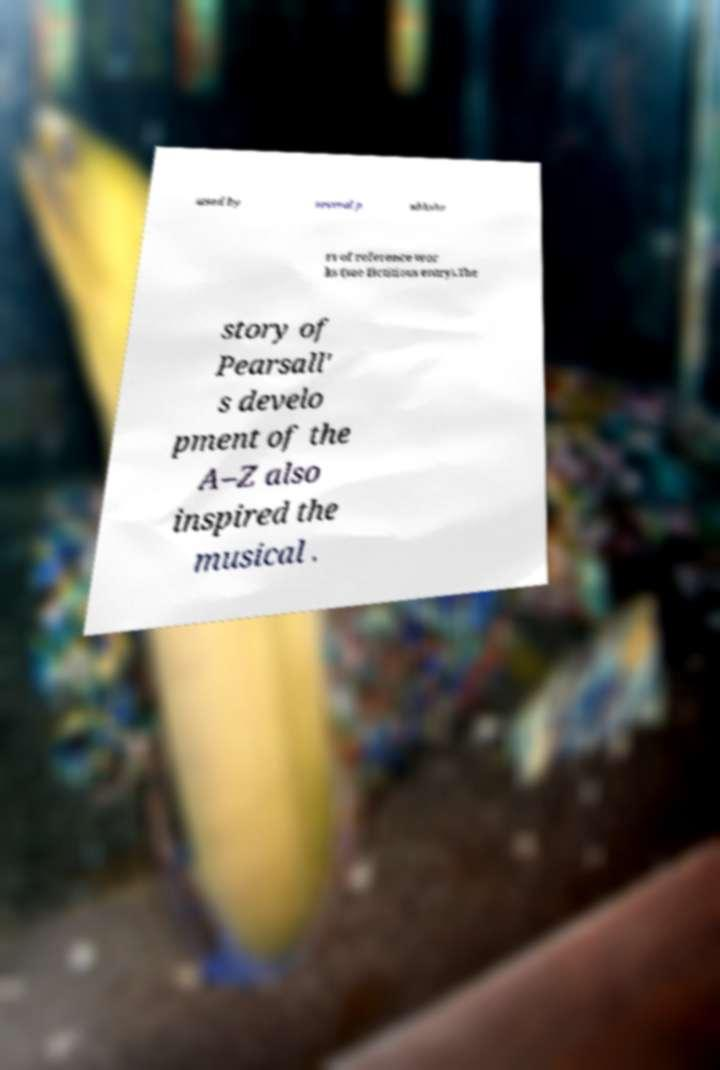Could you extract and type out the text from this image? used by several p ublishe rs of reference wor ks (see fictitious entry).The story of Pearsall' s develo pment of the A–Z also inspired the musical . 